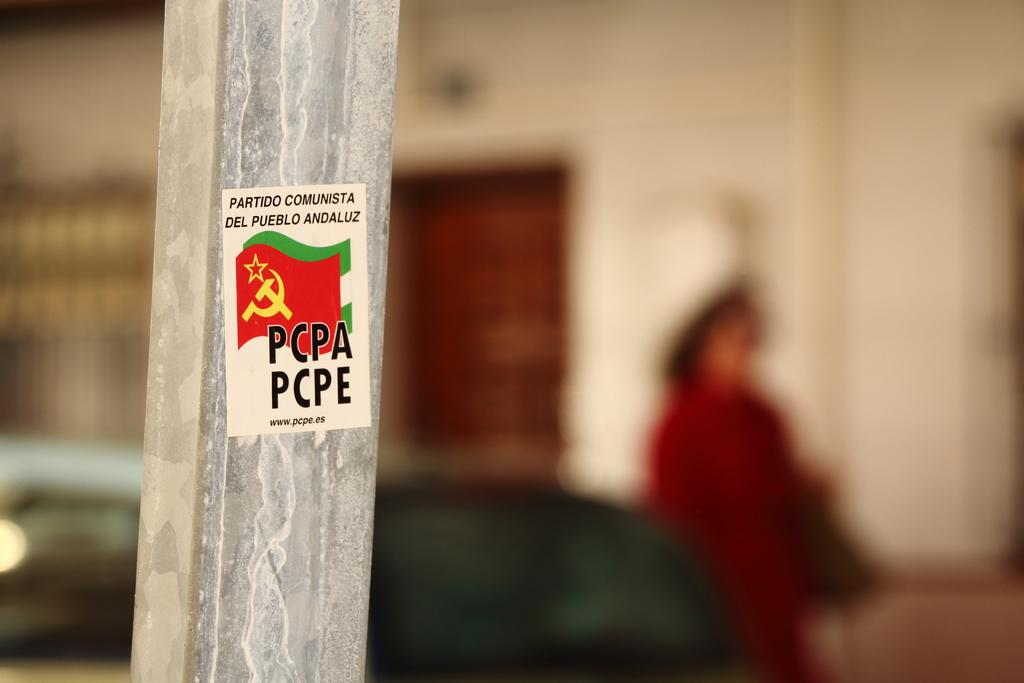What is on the pole in the image? There is a sticker with text and flags on a pole. Can you describe the person in the background? There is a person in the background near a building. How would you describe the background of the image? The background is blurred. What type of mind-reading badge is the person wearing in the image? There is no person wearing a badge in the image, and there is no mention of mind-reading abilities. 